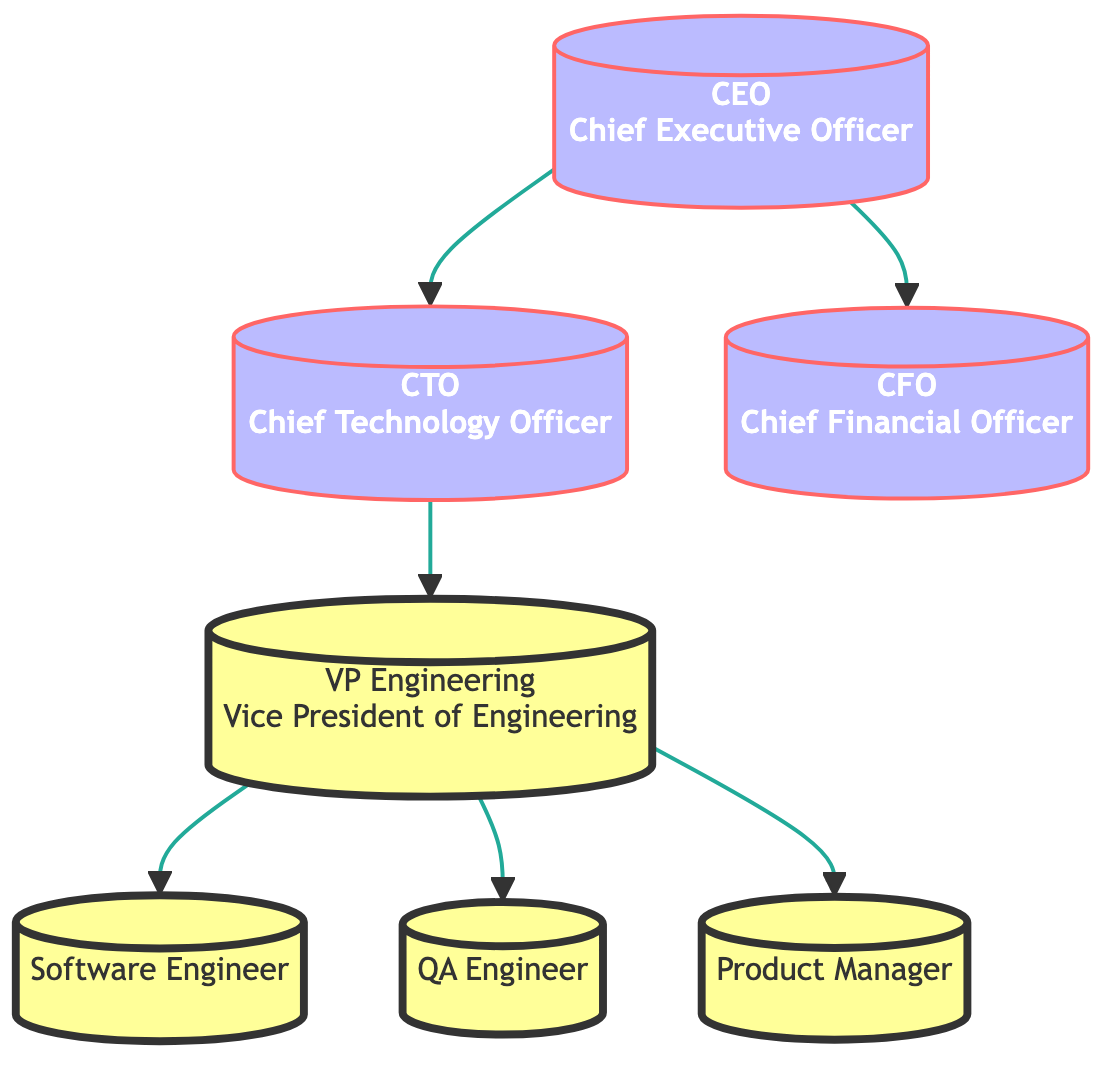What is the top node in the diagram? The top node is the "CEO," as it does not have any other nodes pointing to it, indicating it is the highest level in the hierarchy.
Answer: CEO How many nodes are in the diagram? By counting each distinct position in the diagram, we have a total of 7 nodes: CEO, CTO, CFO, VP Engineering, Product Manager, Software Engineer, and QA Engineer.
Answer: 7 Who reports directly to the CTO? The VP of Engineering reports directly to the CTO, as evidenced by the directed edge from CTO to VP Engineering.
Answer: VP Engineering What role is responsible for managing the financial planning? The role responsible for managing financial planning is the CFO, as indicated by the responsibilities listed for that position.
Answer: CFO Which role coordinates with cross-functional teams? The role that coordinates with cross-functional teams is the Product Manager, as noted in the responsibilities associated with that title.
Answer: Product Manager How many edges are in the diagram? Counting the connections between the nodes in the diagram, there are a total of 6 edges.
Answer: 6 What is the relationship between the CTO and the CFO? There is no direct relationship indicated by the edges in the diagram; they are both directly connected to the CEO but do not connect to each other.
Answer: None Which node has the responsibility to ensure product innovation? The responsibility of ensuring product innovation belongs to the CTO, as specified in the responsibilities under that role.
Answer: CTO What is the hierarchical level of the Software Engineer in relation to the CEO? The Software Engineer is on a lower hierarchical level than the CEO, as it is several steps down in the directed graph structure.
Answer: Lower 